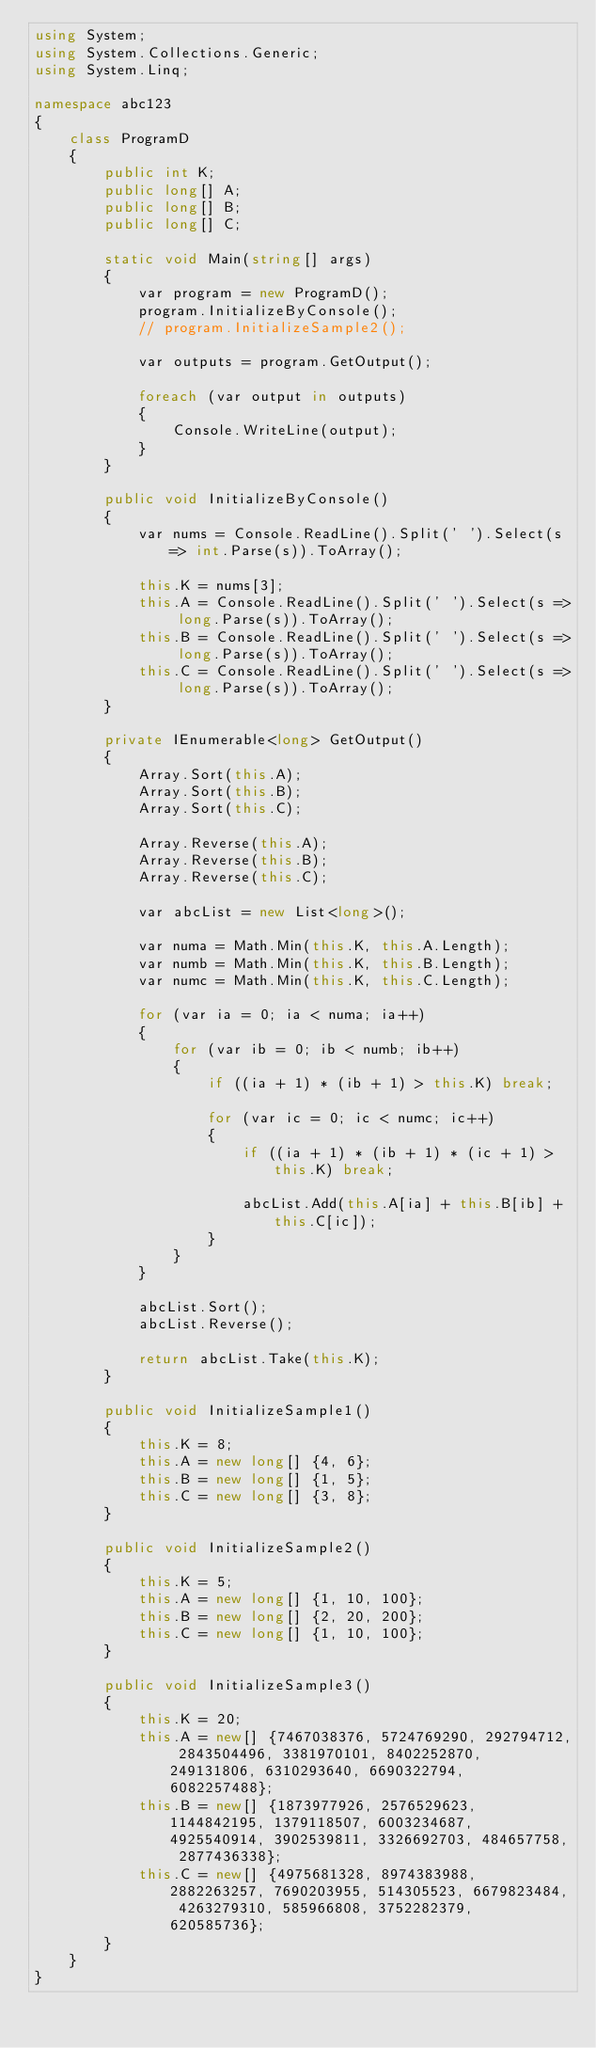Convert code to text. <code><loc_0><loc_0><loc_500><loc_500><_C#_>using System;
using System.Collections.Generic;
using System.Linq;

namespace abc123
{
    class ProgramD
    {
        public int K;
        public long[] A;
        public long[] B;
        public long[] C;

        static void Main(string[] args)
        {
            var program = new ProgramD();
            program.InitializeByConsole();
            // program.InitializeSample2();

            var outputs = program.GetOutput();

            foreach (var output in outputs)
            {
                Console.WriteLine(output);
            }
        }

        public void InitializeByConsole()
        {
            var nums = Console.ReadLine().Split(' ').Select(s => int.Parse(s)).ToArray();

            this.K = nums[3];
            this.A = Console.ReadLine().Split(' ').Select(s => long.Parse(s)).ToArray();
            this.B = Console.ReadLine().Split(' ').Select(s => long.Parse(s)).ToArray();
            this.C = Console.ReadLine().Split(' ').Select(s => long.Parse(s)).ToArray();
        }

        private IEnumerable<long> GetOutput()
        {
            Array.Sort(this.A);
            Array.Sort(this.B);
            Array.Sort(this.C);

            Array.Reverse(this.A);
            Array.Reverse(this.B);
            Array.Reverse(this.C);

            var abcList = new List<long>();

            var numa = Math.Min(this.K, this.A.Length);
            var numb = Math.Min(this.K, this.B.Length);
            var numc = Math.Min(this.K, this.C.Length);

            for (var ia = 0; ia < numa; ia++)
            {
                for (var ib = 0; ib < numb; ib++)
                {
                    if ((ia + 1) * (ib + 1) > this.K) break;

                    for (var ic = 0; ic < numc; ic++)
                    {
                        if ((ia + 1) * (ib + 1) * (ic + 1) > this.K) break;

                        abcList.Add(this.A[ia] + this.B[ib] + this.C[ic]);
                    }
                }
            }

            abcList.Sort();
            abcList.Reverse();

            return abcList.Take(this.K);
        }

        public void InitializeSample1()
        {
            this.K = 8;
            this.A = new long[] {4, 6};
            this.B = new long[] {1, 5};
            this.C = new long[] {3, 8};
        }

        public void InitializeSample2()
        {
            this.K = 5;
            this.A = new long[] {1, 10, 100};
            this.B = new long[] {2, 20, 200};
            this.C = new long[] {1, 10, 100};
        }

        public void InitializeSample3()
        {
            this.K = 20;
            this.A = new[] {7467038376, 5724769290, 292794712, 2843504496, 3381970101, 8402252870, 249131806, 6310293640, 6690322794, 6082257488};
            this.B = new[] {1873977926, 2576529623, 1144842195, 1379118507, 6003234687, 4925540914, 3902539811, 3326692703, 484657758, 2877436338};
            this.C = new[] {4975681328, 8974383988, 2882263257, 7690203955, 514305523, 6679823484, 4263279310, 585966808, 3752282379, 620585736};
        }
    }
}
</code> 